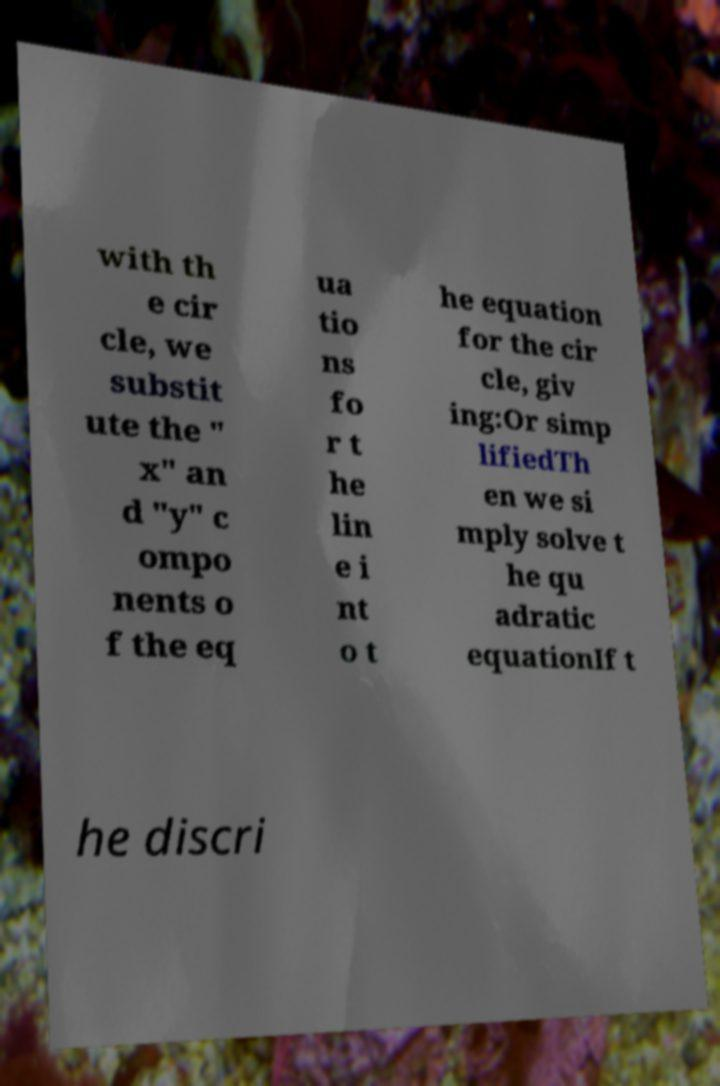There's text embedded in this image that I need extracted. Can you transcribe it verbatim? with th e cir cle, we substit ute the " x" an d "y" c ompo nents o f the eq ua tio ns fo r t he lin e i nt o t he equation for the cir cle, giv ing:Or simp lifiedTh en we si mply solve t he qu adratic equationIf t he discri 